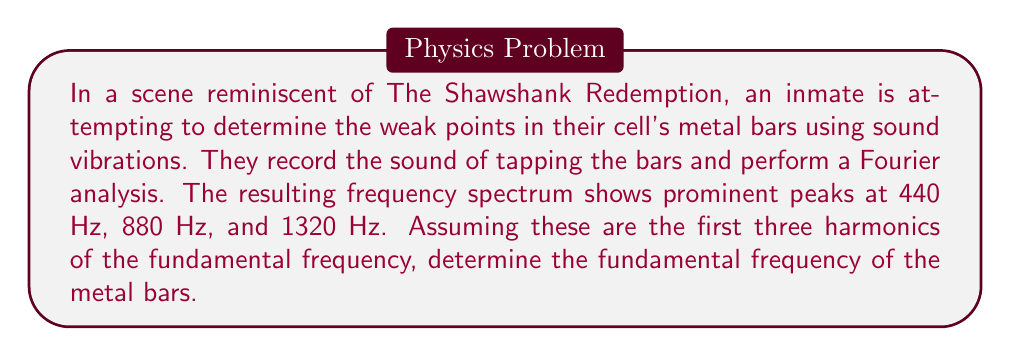Provide a solution to this math problem. To solve this problem, we need to understand the relationship between harmonics and the fundamental frequency in Fourier analysis. In a vibrating system like metal bars:

1) The fundamental frequency ($f_0$) is the lowest frequency of vibration.
2) Harmonics are integer multiples of the fundamental frequency.
3) The $n$-th harmonic frequency is given by $f_n = n \cdot f_0$, where $n$ is a positive integer.

Given information:
- First peak: 440 Hz
- Second peak: 880 Hz
- Third peak: 1320 Hz

Let's analyze these frequencies:

1) If 440 Hz is the fundamental frequency:
   $$f_1 = 440 \text{ Hz}$$
   $$f_2 = 2 \cdot 440 = 880 \text{ Hz}$$
   $$f_3 = 3 \cdot 440 = 1320 \text{ Hz}$$

2) If 440 Hz is the first harmonic (and not the fundamental):
   $$f_1 = 440 \text{ Hz} = 2f_0$$
   $$f_0 = 220 \text{ Hz}$$

   Let's check if this fits the other peaks:
   $$f_2 = 2 \cdot 220 = 440 \text{ Hz}$$
   $$f_3 = 3 \cdot 220 = 660 \text{ Hz}$$
   $$f_4 = 4 \cdot 220 = 880 \text{ Hz}$$
   $$f_6 = 6 \cdot 220 = 1320 \text{ Hz}$$

The second option fits all the given peaks (440 Hz as 2nd harmonic, 880 Hz as 4th harmonic, and 1320 Hz as 6th harmonic). Therefore, the fundamental frequency is 220 Hz.
Answer: The fundamental frequency of the metal bars is 220 Hz. 